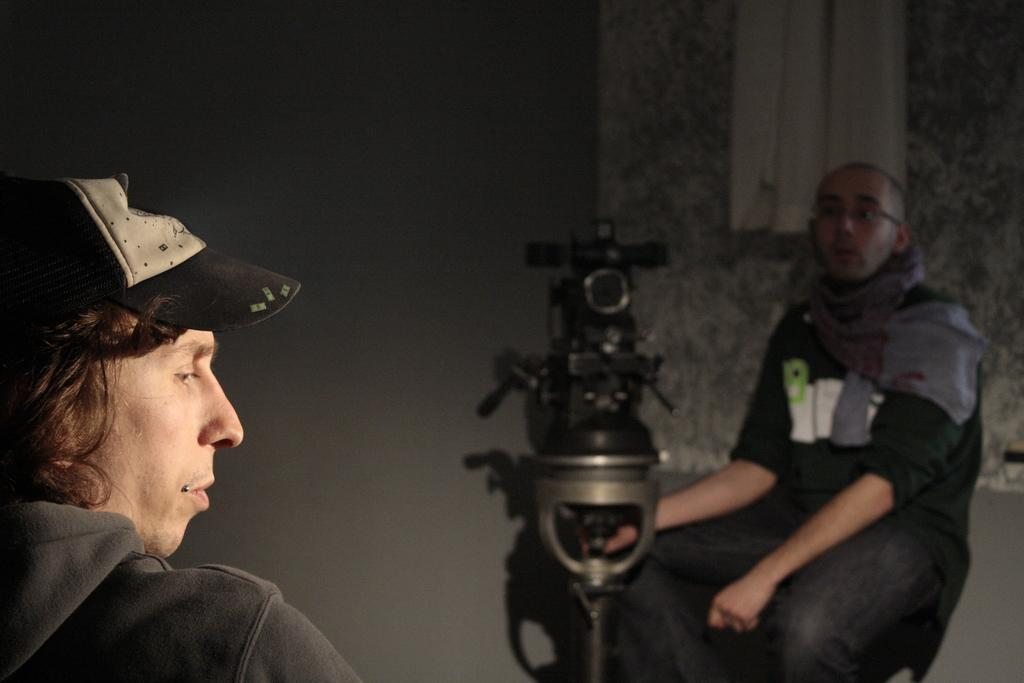How many people are sitting in the image? There are two people sitting in the image. What are the positions of the people in the image? One person is sitting in the bottom left side, and the other person is sitting in the bottom right side. What is the person in the bottom right side holding? The person in the bottom right side is holding a camera. What is behind the person in the bottom right side? There is a wall behind the person in the bottom right side. What type of peace symbol can be seen in the image? There is no peace symbol present in the image. How many crows are visible in the image? There are no crows present in the image. 